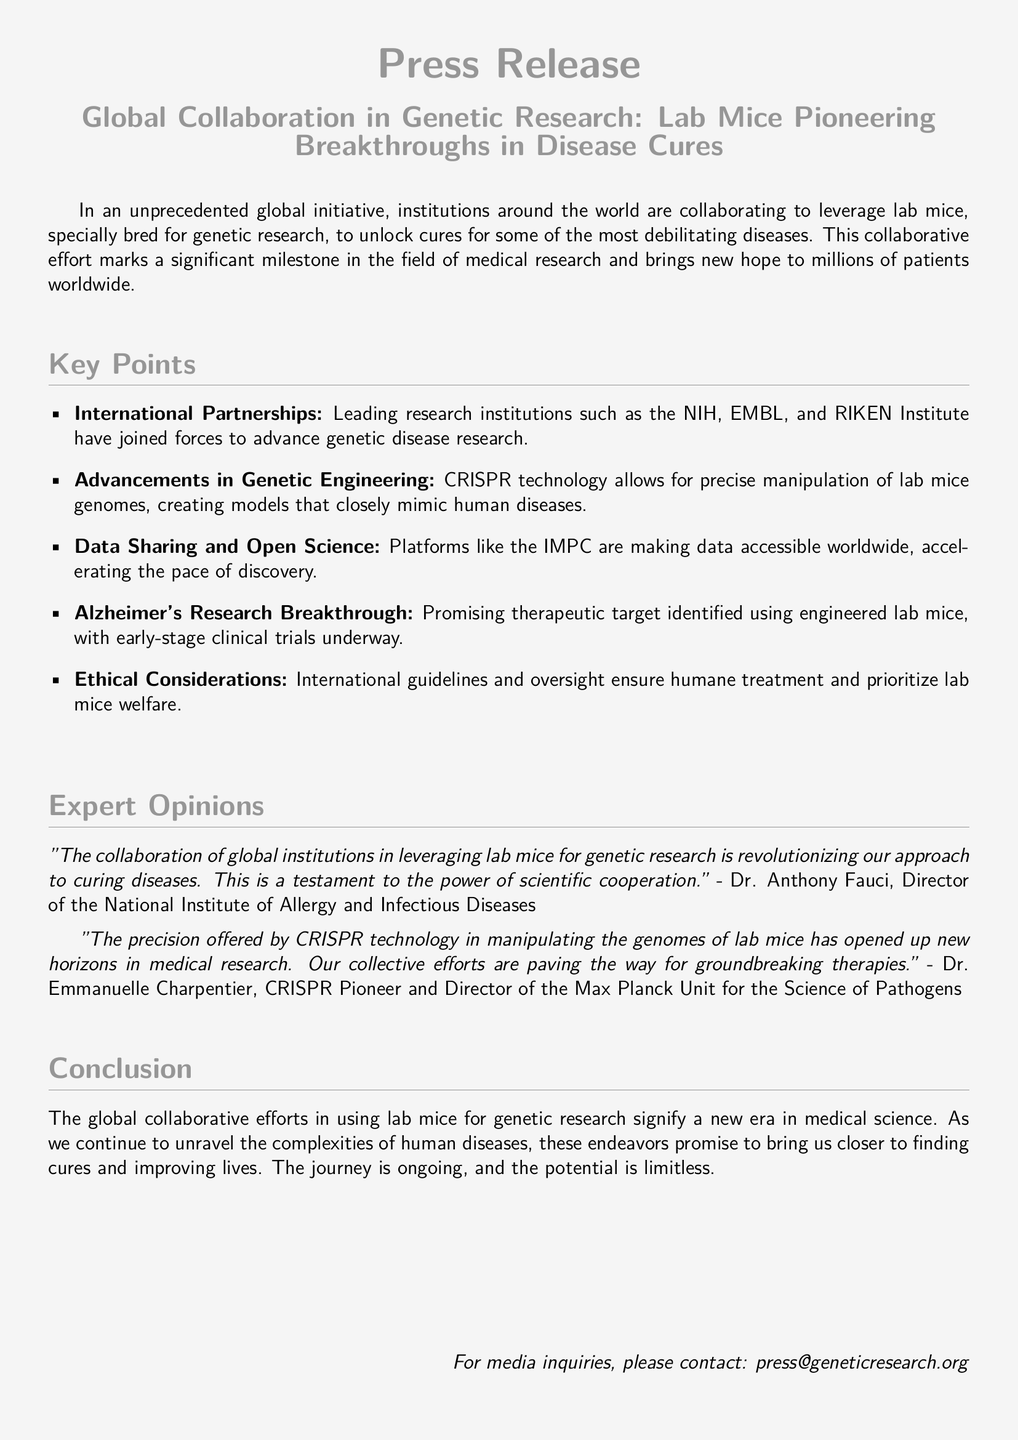What institutions are collaborating on this initiative? The document lists leading research institutions like the NIH, EMBL, and RIKEN Institute as part of the collaboration.
Answer: NIH, EMBL, RIKEN Institute What technology allows precise manipulation of lab mice genomes? The document states that CRISPR technology is used for the precise manipulation of lab mice genomes.
Answer: CRISPR What therapeutic area is highlighted for breakthrough research in the document? The document mentions that a promising therapeutic target has been identified for Alzheimer's research.
Answer: Alzheimer's Who is the Director of the National Institute of Allergy and Infectious Diseases? According to the document, Dr. Anthony Fauci holds this position.
Answer: Dr. Anthony Fauci What platform is mentioned as aiding in data accessibility worldwide? The document highlights the IMPC as a platform making data accessible globally.
Answer: IMPC What is the main focus of the global collaborative efforts in this research? The document states the focus is on using lab mice for genetic research to unlock cures for diseases.
Answer: Unlock cures for diseases What is emphasized regarding lab mice welfare in the document? The document notes that ethical considerations and international guidelines ensure humane treatment and prioritize lab mice welfare.
Answer: Humane treatment How does Dr. Emmanuelle Charpentier describe the impact of CRISPR technology? The document quotes Dr. Emmanuelle Charpentier saying it has opened up new horizons in medical research.
Answer: New horizons in medical research 